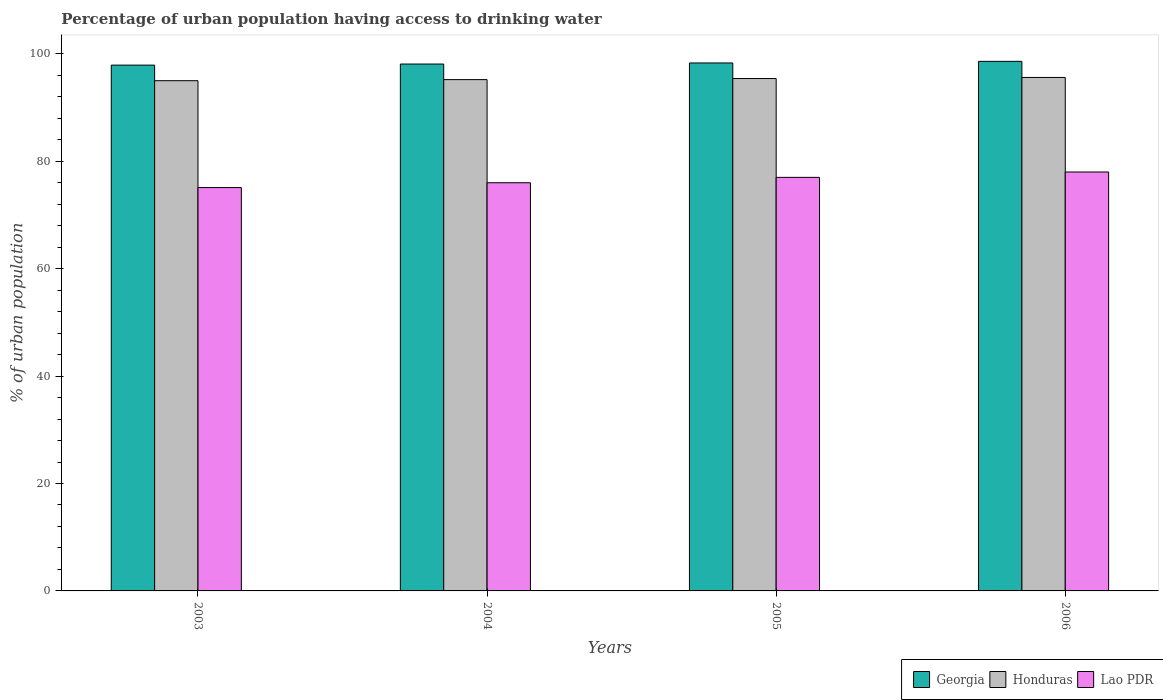How many groups of bars are there?
Make the answer very short. 4. Are the number of bars per tick equal to the number of legend labels?
Offer a very short reply. Yes. Are the number of bars on each tick of the X-axis equal?
Your answer should be compact. Yes. How many bars are there on the 4th tick from the left?
Offer a very short reply. 3. What is the label of the 2nd group of bars from the left?
Offer a terse response. 2004. In how many cases, is the number of bars for a given year not equal to the number of legend labels?
Keep it short and to the point. 0. What is the percentage of urban population having access to drinking water in Georgia in 2006?
Your answer should be compact. 98.6. Across all years, what is the maximum percentage of urban population having access to drinking water in Honduras?
Keep it short and to the point. 95.6. In which year was the percentage of urban population having access to drinking water in Lao PDR maximum?
Provide a succinct answer. 2006. In which year was the percentage of urban population having access to drinking water in Honduras minimum?
Give a very brief answer. 2003. What is the total percentage of urban population having access to drinking water in Lao PDR in the graph?
Your answer should be very brief. 306.1. What is the difference between the percentage of urban population having access to drinking water in Lao PDR in 2003 and that in 2004?
Your response must be concise. -0.9. What is the difference between the percentage of urban population having access to drinking water in Lao PDR in 2005 and the percentage of urban population having access to drinking water in Honduras in 2006?
Keep it short and to the point. -18.6. What is the average percentage of urban population having access to drinking water in Georgia per year?
Your answer should be compact. 98.22. In the year 2003, what is the difference between the percentage of urban population having access to drinking water in Lao PDR and percentage of urban population having access to drinking water in Honduras?
Your answer should be very brief. -19.9. What is the ratio of the percentage of urban population having access to drinking water in Lao PDR in 2004 to that in 2005?
Your answer should be compact. 0.99. What is the difference between the highest and the second highest percentage of urban population having access to drinking water in Honduras?
Offer a terse response. 0.2. What is the difference between the highest and the lowest percentage of urban population having access to drinking water in Georgia?
Give a very brief answer. 0.7. In how many years, is the percentage of urban population having access to drinking water in Georgia greater than the average percentage of urban population having access to drinking water in Georgia taken over all years?
Your response must be concise. 2. Is the sum of the percentage of urban population having access to drinking water in Georgia in 2005 and 2006 greater than the maximum percentage of urban population having access to drinking water in Lao PDR across all years?
Your response must be concise. Yes. What does the 1st bar from the left in 2003 represents?
Your answer should be compact. Georgia. What does the 2nd bar from the right in 2004 represents?
Ensure brevity in your answer.  Honduras. Is it the case that in every year, the sum of the percentage of urban population having access to drinking water in Honduras and percentage of urban population having access to drinking water in Georgia is greater than the percentage of urban population having access to drinking water in Lao PDR?
Ensure brevity in your answer.  Yes. Are all the bars in the graph horizontal?
Your answer should be compact. No. How many years are there in the graph?
Offer a terse response. 4. What is the difference between two consecutive major ticks on the Y-axis?
Your response must be concise. 20. Are the values on the major ticks of Y-axis written in scientific E-notation?
Provide a short and direct response. No. Does the graph contain any zero values?
Your response must be concise. No. Where does the legend appear in the graph?
Provide a short and direct response. Bottom right. How are the legend labels stacked?
Provide a succinct answer. Horizontal. What is the title of the graph?
Offer a very short reply. Percentage of urban population having access to drinking water. Does "Kazakhstan" appear as one of the legend labels in the graph?
Ensure brevity in your answer.  No. What is the label or title of the X-axis?
Make the answer very short. Years. What is the label or title of the Y-axis?
Offer a very short reply. % of urban population. What is the % of urban population of Georgia in 2003?
Provide a succinct answer. 97.9. What is the % of urban population in Lao PDR in 2003?
Your answer should be compact. 75.1. What is the % of urban population in Georgia in 2004?
Make the answer very short. 98.1. What is the % of urban population in Honduras in 2004?
Provide a short and direct response. 95.2. What is the % of urban population in Georgia in 2005?
Make the answer very short. 98.3. What is the % of urban population of Honduras in 2005?
Provide a succinct answer. 95.4. What is the % of urban population of Georgia in 2006?
Give a very brief answer. 98.6. What is the % of urban population of Honduras in 2006?
Your response must be concise. 95.6. Across all years, what is the maximum % of urban population of Georgia?
Offer a terse response. 98.6. Across all years, what is the maximum % of urban population of Honduras?
Your answer should be compact. 95.6. Across all years, what is the maximum % of urban population of Lao PDR?
Give a very brief answer. 78. Across all years, what is the minimum % of urban population in Georgia?
Provide a short and direct response. 97.9. Across all years, what is the minimum % of urban population of Honduras?
Offer a very short reply. 95. Across all years, what is the minimum % of urban population of Lao PDR?
Provide a short and direct response. 75.1. What is the total % of urban population of Georgia in the graph?
Give a very brief answer. 392.9. What is the total % of urban population of Honduras in the graph?
Provide a succinct answer. 381.2. What is the total % of urban population in Lao PDR in the graph?
Keep it short and to the point. 306.1. What is the difference between the % of urban population in Georgia in 2003 and that in 2004?
Offer a very short reply. -0.2. What is the difference between the % of urban population of Honduras in 2003 and that in 2004?
Ensure brevity in your answer.  -0.2. What is the difference between the % of urban population of Lao PDR in 2003 and that in 2004?
Your answer should be compact. -0.9. What is the difference between the % of urban population in Georgia in 2003 and that in 2005?
Provide a succinct answer. -0.4. What is the difference between the % of urban population in Lao PDR in 2003 and that in 2005?
Offer a very short reply. -1.9. What is the difference between the % of urban population of Georgia in 2003 and that in 2006?
Ensure brevity in your answer.  -0.7. What is the difference between the % of urban population of Lao PDR in 2003 and that in 2006?
Keep it short and to the point. -2.9. What is the difference between the % of urban population of Honduras in 2004 and that in 2005?
Provide a succinct answer. -0.2. What is the difference between the % of urban population of Georgia in 2005 and that in 2006?
Your response must be concise. -0.3. What is the difference between the % of urban population in Honduras in 2005 and that in 2006?
Offer a terse response. -0.2. What is the difference between the % of urban population in Lao PDR in 2005 and that in 2006?
Provide a succinct answer. -1. What is the difference between the % of urban population in Georgia in 2003 and the % of urban population in Honduras in 2004?
Give a very brief answer. 2.7. What is the difference between the % of urban population of Georgia in 2003 and the % of urban population of Lao PDR in 2004?
Ensure brevity in your answer.  21.9. What is the difference between the % of urban population of Honduras in 2003 and the % of urban population of Lao PDR in 2004?
Offer a terse response. 19. What is the difference between the % of urban population of Georgia in 2003 and the % of urban population of Lao PDR in 2005?
Give a very brief answer. 20.9. What is the difference between the % of urban population of Georgia in 2003 and the % of urban population of Honduras in 2006?
Offer a terse response. 2.3. What is the difference between the % of urban population in Honduras in 2003 and the % of urban population in Lao PDR in 2006?
Provide a succinct answer. 17. What is the difference between the % of urban population of Georgia in 2004 and the % of urban population of Lao PDR in 2005?
Make the answer very short. 21.1. What is the difference between the % of urban population in Georgia in 2004 and the % of urban population in Honduras in 2006?
Provide a succinct answer. 2.5. What is the difference between the % of urban population in Georgia in 2004 and the % of urban population in Lao PDR in 2006?
Your answer should be compact. 20.1. What is the difference between the % of urban population in Georgia in 2005 and the % of urban population in Lao PDR in 2006?
Give a very brief answer. 20.3. What is the average % of urban population of Georgia per year?
Give a very brief answer. 98.22. What is the average % of urban population of Honduras per year?
Make the answer very short. 95.3. What is the average % of urban population in Lao PDR per year?
Give a very brief answer. 76.53. In the year 2003, what is the difference between the % of urban population of Georgia and % of urban population of Lao PDR?
Offer a very short reply. 22.8. In the year 2004, what is the difference between the % of urban population of Georgia and % of urban population of Lao PDR?
Provide a succinct answer. 22.1. In the year 2004, what is the difference between the % of urban population in Honduras and % of urban population in Lao PDR?
Provide a succinct answer. 19.2. In the year 2005, what is the difference between the % of urban population in Georgia and % of urban population in Honduras?
Your answer should be compact. 2.9. In the year 2005, what is the difference between the % of urban population in Georgia and % of urban population in Lao PDR?
Provide a short and direct response. 21.3. In the year 2005, what is the difference between the % of urban population in Honduras and % of urban population in Lao PDR?
Your response must be concise. 18.4. In the year 2006, what is the difference between the % of urban population in Georgia and % of urban population in Honduras?
Ensure brevity in your answer.  3. In the year 2006, what is the difference between the % of urban population in Georgia and % of urban population in Lao PDR?
Ensure brevity in your answer.  20.6. What is the ratio of the % of urban population in Georgia in 2003 to that in 2004?
Offer a very short reply. 1. What is the ratio of the % of urban population in Lao PDR in 2003 to that in 2005?
Provide a succinct answer. 0.98. What is the ratio of the % of urban population of Honduras in 2003 to that in 2006?
Keep it short and to the point. 0.99. What is the ratio of the % of urban population in Lao PDR in 2003 to that in 2006?
Your response must be concise. 0.96. What is the ratio of the % of urban population in Lao PDR in 2004 to that in 2006?
Offer a very short reply. 0.97. What is the ratio of the % of urban population of Georgia in 2005 to that in 2006?
Offer a terse response. 1. What is the ratio of the % of urban population in Honduras in 2005 to that in 2006?
Your answer should be compact. 1. What is the ratio of the % of urban population of Lao PDR in 2005 to that in 2006?
Keep it short and to the point. 0.99. What is the difference between the highest and the second highest % of urban population of Georgia?
Provide a succinct answer. 0.3. What is the difference between the highest and the second highest % of urban population of Honduras?
Provide a succinct answer. 0.2. 